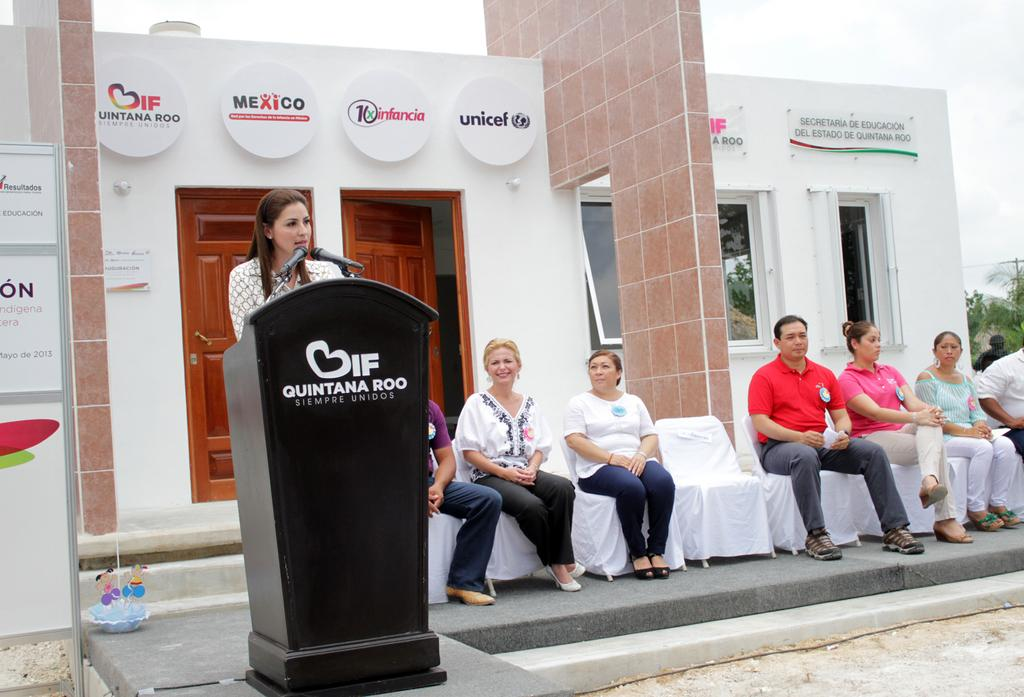<image>
Provide a brief description of the given image. A female is giving a speech from a podium that says Quintana Roo on it. 